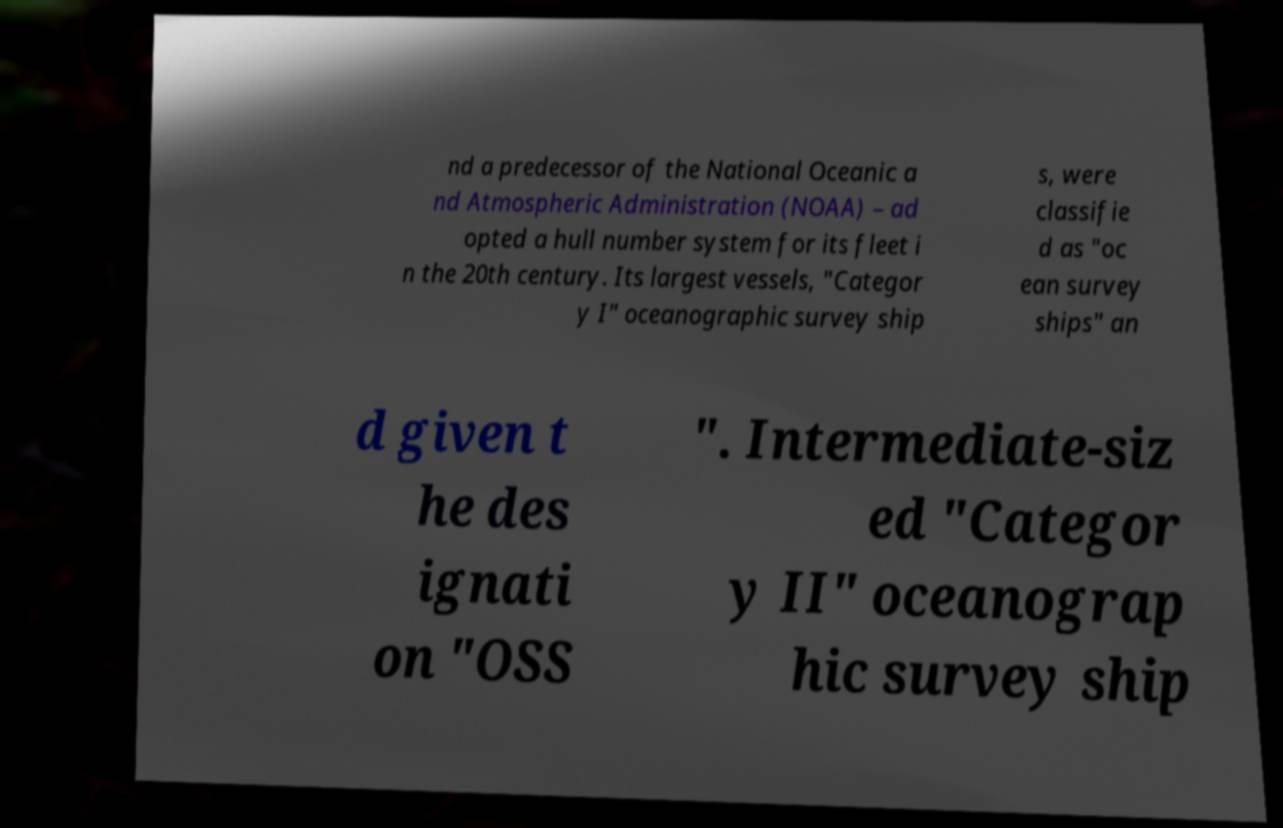Could you extract and type out the text from this image? nd a predecessor of the National Oceanic a nd Atmospheric Administration (NOAA) – ad opted a hull number system for its fleet i n the 20th century. Its largest vessels, "Categor y I" oceanographic survey ship s, were classifie d as "oc ean survey ships" an d given t he des ignati on "OSS ". Intermediate-siz ed "Categor y II" oceanograp hic survey ship 